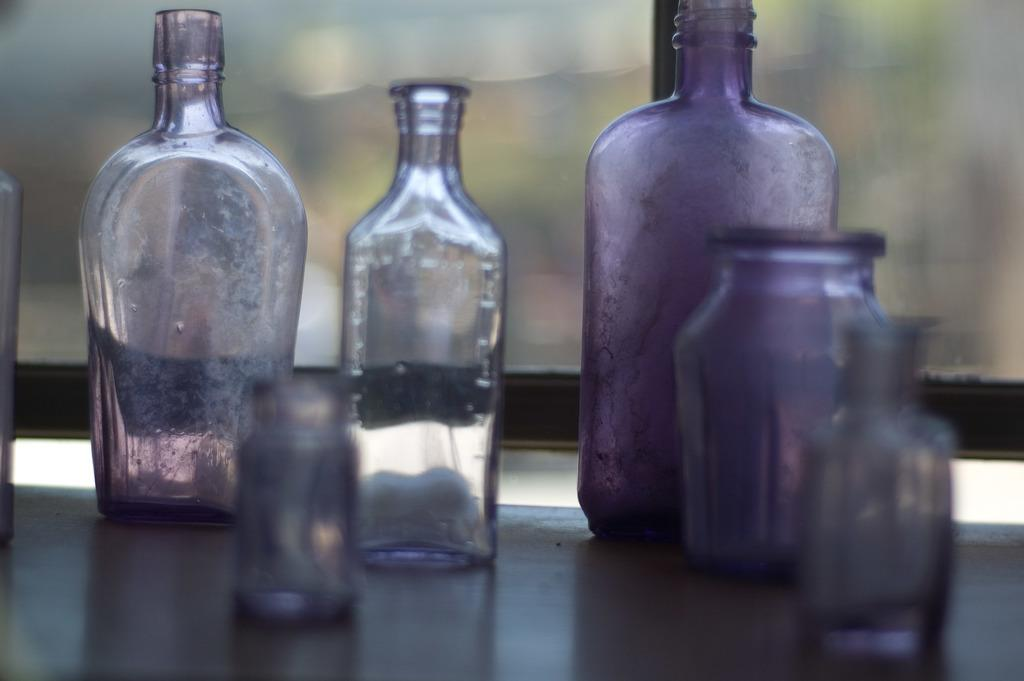What type of containers are visible in the image? There are glass bottles in the image. What type of lipstick is the brother using in the image? There is no brother or lipstick present in the image; it only features glass bottles. 